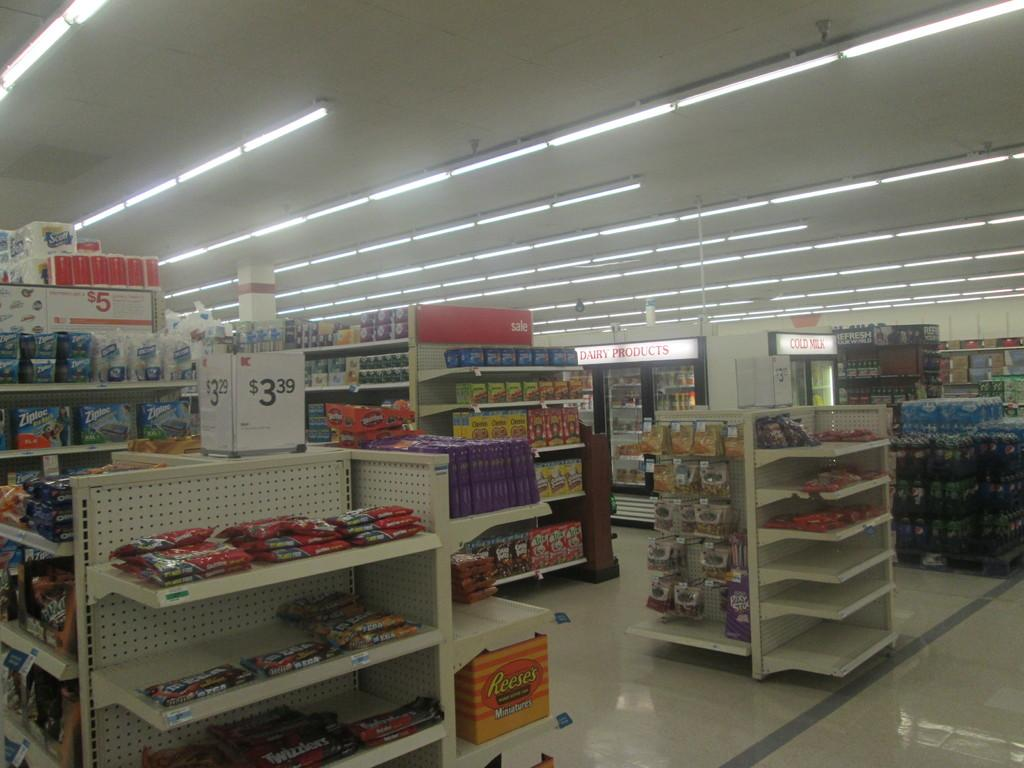<image>
Write a terse but informative summary of the picture. a store with something that is for sale at 3.39 